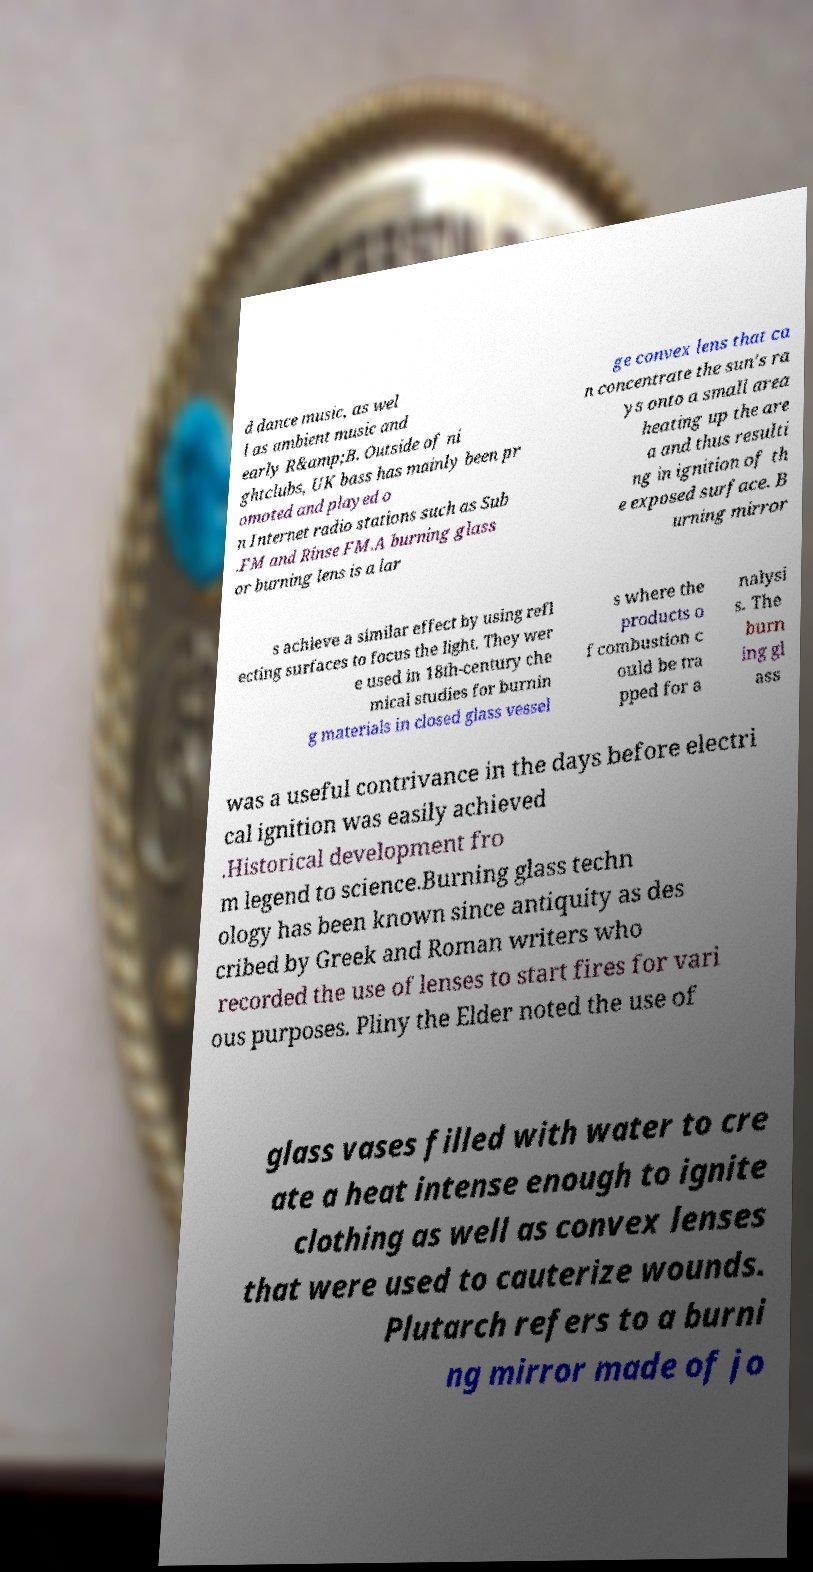I need the written content from this picture converted into text. Can you do that? d dance music, as wel l as ambient music and early R&amp;B. Outside of ni ghtclubs, UK bass has mainly been pr omoted and played o n Internet radio stations such as Sub .FM and Rinse FM.A burning glass or burning lens is a lar ge convex lens that ca n concentrate the sun's ra ys onto a small area heating up the are a and thus resulti ng in ignition of th e exposed surface. B urning mirror s achieve a similar effect by using refl ecting surfaces to focus the light. They wer e used in 18th-century che mical studies for burnin g materials in closed glass vessel s where the products o f combustion c ould be tra pped for a nalysi s. The burn ing gl ass was a useful contrivance in the days before electri cal ignition was easily achieved .Historical development fro m legend to science.Burning glass techn ology has been known since antiquity as des cribed by Greek and Roman writers who recorded the use of lenses to start fires for vari ous purposes. Pliny the Elder noted the use of glass vases filled with water to cre ate a heat intense enough to ignite clothing as well as convex lenses that were used to cauterize wounds. Plutarch refers to a burni ng mirror made of jo 